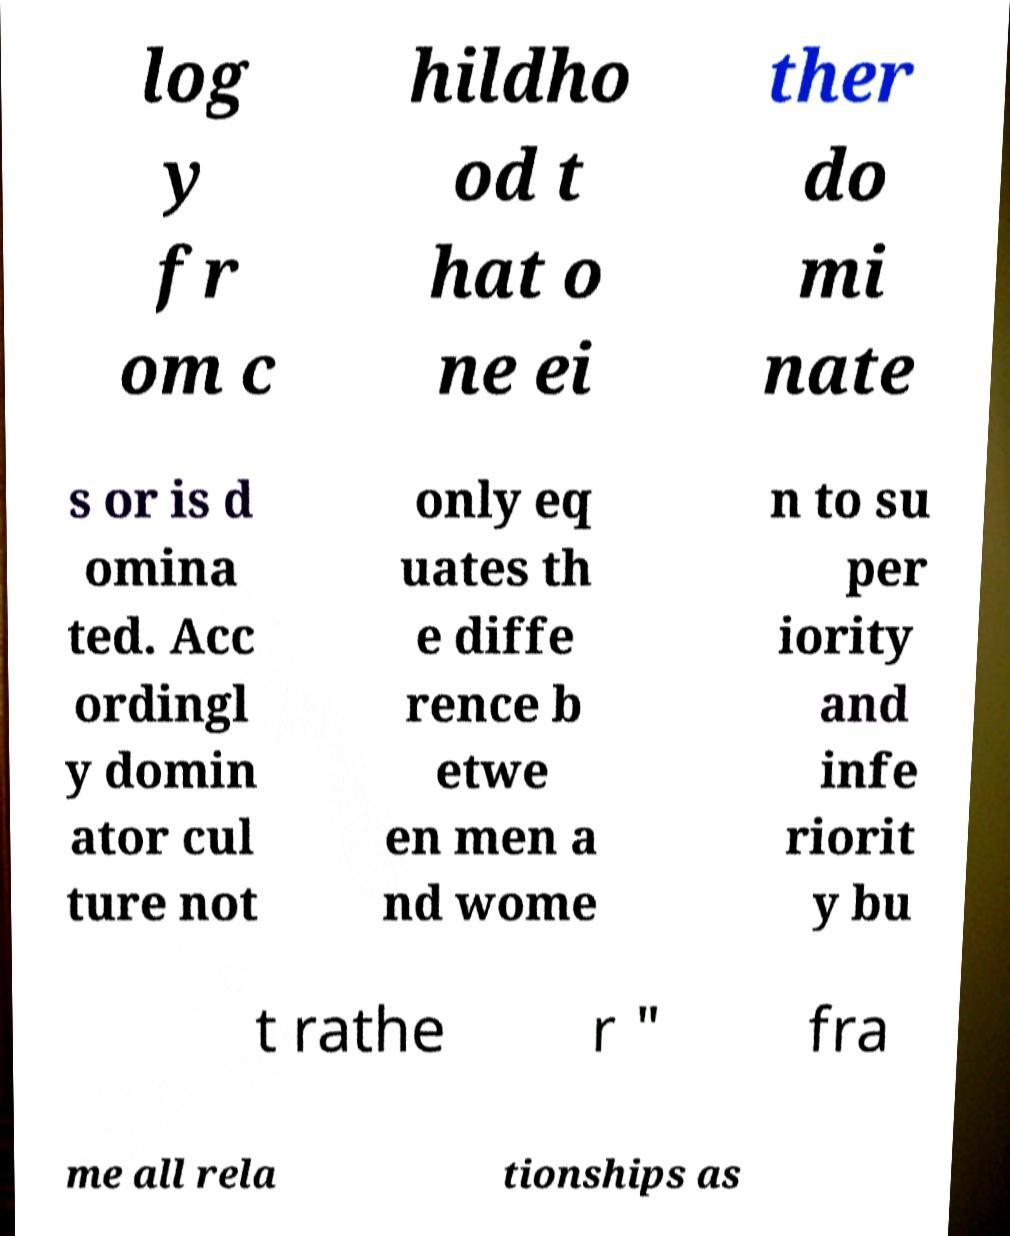Please identify and transcribe the text found in this image. log y fr om c hildho od t hat o ne ei ther do mi nate s or is d omina ted. Acc ordingl y domin ator cul ture not only eq uates th e diffe rence b etwe en men a nd wome n to su per iority and infe riorit y bu t rathe r " fra me all rela tionships as 